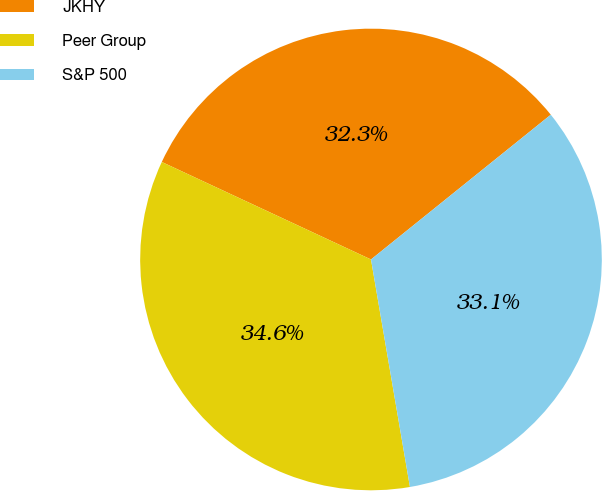Convert chart. <chart><loc_0><loc_0><loc_500><loc_500><pie_chart><fcel>JKHY<fcel>Peer Group<fcel>S&P 500<nl><fcel>32.27%<fcel>34.64%<fcel>33.09%<nl></chart> 